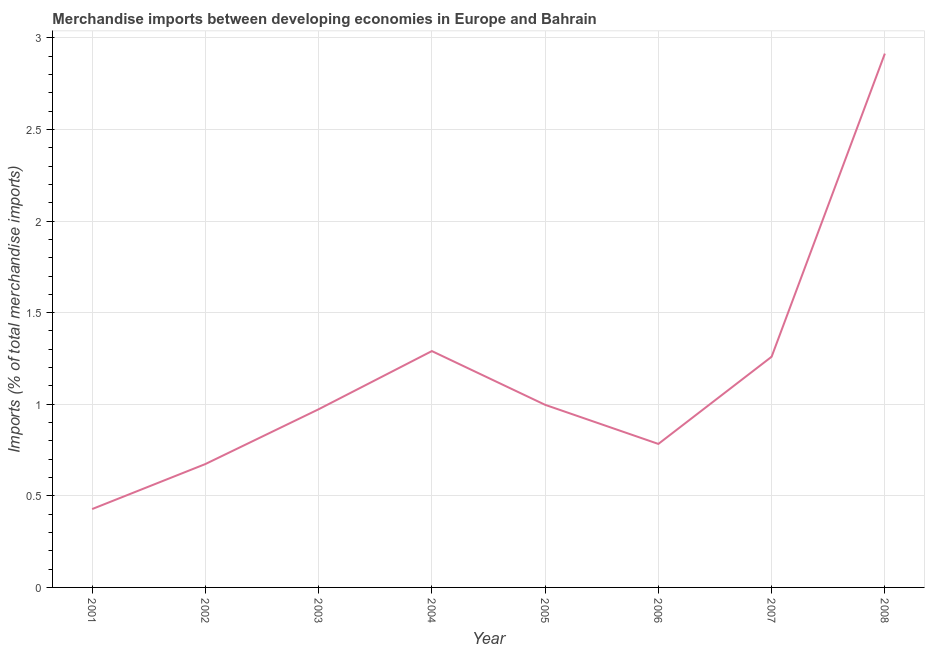What is the merchandise imports in 2002?
Make the answer very short. 0.67. Across all years, what is the maximum merchandise imports?
Your answer should be very brief. 2.91. Across all years, what is the minimum merchandise imports?
Offer a terse response. 0.43. What is the sum of the merchandise imports?
Offer a terse response. 9.32. What is the difference between the merchandise imports in 2001 and 2003?
Ensure brevity in your answer.  -0.54. What is the average merchandise imports per year?
Your answer should be compact. 1.16. What is the median merchandise imports?
Your response must be concise. 0.98. What is the ratio of the merchandise imports in 2004 to that in 2005?
Offer a very short reply. 1.29. Is the merchandise imports in 2003 less than that in 2006?
Provide a short and direct response. No. What is the difference between the highest and the second highest merchandise imports?
Give a very brief answer. 1.62. What is the difference between the highest and the lowest merchandise imports?
Provide a short and direct response. 2.49. In how many years, is the merchandise imports greater than the average merchandise imports taken over all years?
Offer a terse response. 3. What is the difference between two consecutive major ticks on the Y-axis?
Your answer should be very brief. 0.5. Are the values on the major ticks of Y-axis written in scientific E-notation?
Provide a succinct answer. No. What is the title of the graph?
Provide a short and direct response. Merchandise imports between developing economies in Europe and Bahrain. What is the label or title of the Y-axis?
Your response must be concise. Imports (% of total merchandise imports). What is the Imports (% of total merchandise imports) of 2001?
Provide a succinct answer. 0.43. What is the Imports (% of total merchandise imports) in 2002?
Your response must be concise. 0.67. What is the Imports (% of total merchandise imports) in 2003?
Your response must be concise. 0.97. What is the Imports (% of total merchandise imports) of 2004?
Provide a succinct answer. 1.29. What is the Imports (% of total merchandise imports) of 2005?
Provide a succinct answer. 1. What is the Imports (% of total merchandise imports) of 2006?
Keep it short and to the point. 0.78. What is the Imports (% of total merchandise imports) in 2007?
Provide a succinct answer. 1.26. What is the Imports (% of total merchandise imports) of 2008?
Make the answer very short. 2.91. What is the difference between the Imports (% of total merchandise imports) in 2001 and 2002?
Ensure brevity in your answer.  -0.25. What is the difference between the Imports (% of total merchandise imports) in 2001 and 2003?
Provide a short and direct response. -0.54. What is the difference between the Imports (% of total merchandise imports) in 2001 and 2004?
Ensure brevity in your answer.  -0.86. What is the difference between the Imports (% of total merchandise imports) in 2001 and 2005?
Offer a terse response. -0.57. What is the difference between the Imports (% of total merchandise imports) in 2001 and 2006?
Offer a terse response. -0.36. What is the difference between the Imports (% of total merchandise imports) in 2001 and 2007?
Ensure brevity in your answer.  -0.83. What is the difference between the Imports (% of total merchandise imports) in 2001 and 2008?
Make the answer very short. -2.49. What is the difference between the Imports (% of total merchandise imports) in 2002 and 2003?
Offer a terse response. -0.3. What is the difference between the Imports (% of total merchandise imports) in 2002 and 2004?
Ensure brevity in your answer.  -0.62. What is the difference between the Imports (% of total merchandise imports) in 2002 and 2005?
Your response must be concise. -0.32. What is the difference between the Imports (% of total merchandise imports) in 2002 and 2006?
Give a very brief answer. -0.11. What is the difference between the Imports (% of total merchandise imports) in 2002 and 2007?
Keep it short and to the point. -0.59. What is the difference between the Imports (% of total merchandise imports) in 2002 and 2008?
Give a very brief answer. -2.24. What is the difference between the Imports (% of total merchandise imports) in 2003 and 2004?
Offer a terse response. -0.32. What is the difference between the Imports (% of total merchandise imports) in 2003 and 2005?
Keep it short and to the point. -0.02. What is the difference between the Imports (% of total merchandise imports) in 2003 and 2006?
Give a very brief answer. 0.19. What is the difference between the Imports (% of total merchandise imports) in 2003 and 2007?
Offer a very short reply. -0.29. What is the difference between the Imports (% of total merchandise imports) in 2003 and 2008?
Keep it short and to the point. -1.94. What is the difference between the Imports (% of total merchandise imports) in 2004 and 2005?
Your answer should be compact. 0.29. What is the difference between the Imports (% of total merchandise imports) in 2004 and 2006?
Ensure brevity in your answer.  0.51. What is the difference between the Imports (% of total merchandise imports) in 2004 and 2007?
Provide a short and direct response. 0.03. What is the difference between the Imports (% of total merchandise imports) in 2004 and 2008?
Make the answer very short. -1.62. What is the difference between the Imports (% of total merchandise imports) in 2005 and 2006?
Your answer should be compact. 0.21. What is the difference between the Imports (% of total merchandise imports) in 2005 and 2007?
Your answer should be very brief. -0.26. What is the difference between the Imports (% of total merchandise imports) in 2005 and 2008?
Your answer should be very brief. -1.92. What is the difference between the Imports (% of total merchandise imports) in 2006 and 2007?
Ensure brevity in your answer.  -0.48. What is the difference between the Imports (% of total merchandise imports) in 2006 and 2008?
Provide a short and direct response. -2.13. What is the difference between the Imports (% of total merchandise imports) in 2007 and 2008?
Provide a succinct answer. -1.65. What is the ratio of the Imports (% of total merchandise imports) in 2001 to that in 2002?
Your answer should be compact. 0.64. What is the ratio of the Imports (% of total merchandise imports) in 2001 to that in 2003?
Provide a short and direct response. 0.44. What is the ratio of the Imports (% of total merchandise imports) in 2001 to that in 2004?
Keep it short and to the point. 0.33. What is the ratio of the Imports (% of total merchandise imports) in 2001 to that in 2005?
Make the answer very short. 0.43. What is the ratio of the Imports (% of total merchandise imports) in 2001 to that in 2006?
Offer a terse response. 0.55. What is the ratio of the Imports (% of total merchandise imports) in 2001 to that in 2007?
Make the answer very short. 0.34. What is the ratio of the Imports (% of total merchandise imports) in 2001 to that in 2008?
Offer a terse response. 0.15. What is the ratio of the Imports (% of total merchandise imports) in 2002 to that in 2003?
Keep it short and to the point. 0.69. What is the ratio of the Imports (% of total merchandise imports) in 2002 to that in 2004?
Your answer should be compact. 0.52. What is the ratio of the Imports (% of total merchandise imports) in 2002 to that in 2005?
Offer a terse response. 0.68. What is the ratio of the Imports (% of total merchandise imports) in 2002 to that in 2006?
Make the answer very short. 0.86. What is the ratio of the Imports (% of total merchandise imports) in 2002 to that in 2007?
Your response must be concise. 0.54. What is the ratio of the Imports (% of total merchandise imports) in 2002 to that in 2008?
Make the answer very short. 0.23. What is the ratio of the Imports (% of total merchandise imports) in 2003 to that in 2004?
Your response must be concise. 0.75. What is the ratio of the Imports (% of total merchandise imports) in 2003 to that in 2006?
Make the answer very short. 1.24. What is the ratio of the Imports (% of total merchandise imports) in 2003 to that in 2007?
Your answer should be very brief. 0.77. What is the ratio of the Imports (% of total merchandise imports) in 2003 to that in 2008?
Keep it short and to the point. 0.33. What is the ratio of the Imports (% of total merchandise imports) in 2004 to that in 2005?
Offer a terse response. 1.29. What is the ratio of the Imports (% of total merchandise imports) in 2004 to that in 2006?
Your answer should be compact. 1.65. What is the ratio of the Imports (% of total merchandise imports) in 2004 to that in 2007?
Offer a very short reply. 1.02. What is the ratio of the Imports (% of total merchandise imports) in 2004 to that in 2008?
Provide a succinct answer. 0.44. What is the ratio of the Imports (% of total merchandise imports) in 2005 to that in 2006?
Provide a short and direct response. 1.27. What is the ratio of the Imports (% of total merchandise imports) in 2005 to that in 2007?
Provide a short and direct response. 0.79. What is the ratio of the Imports (% of total merchandise imports) in 2005 to that in 2008?
Give a very brief answer. 0.34. What is the ratio of the Imports (% of total merchandise imports) in 2006 to that in 2007?
Offer a very short reply. 0.62. What is the ratio of the Imports (% of total merchandise imports) in 2006 to that in 2008?
Offer a terse response. 0.27. What is the ratio of the Imports (% of total merchandise imports) in 2007 to that in 2008?
Provide a short and direct response. 0.43. 